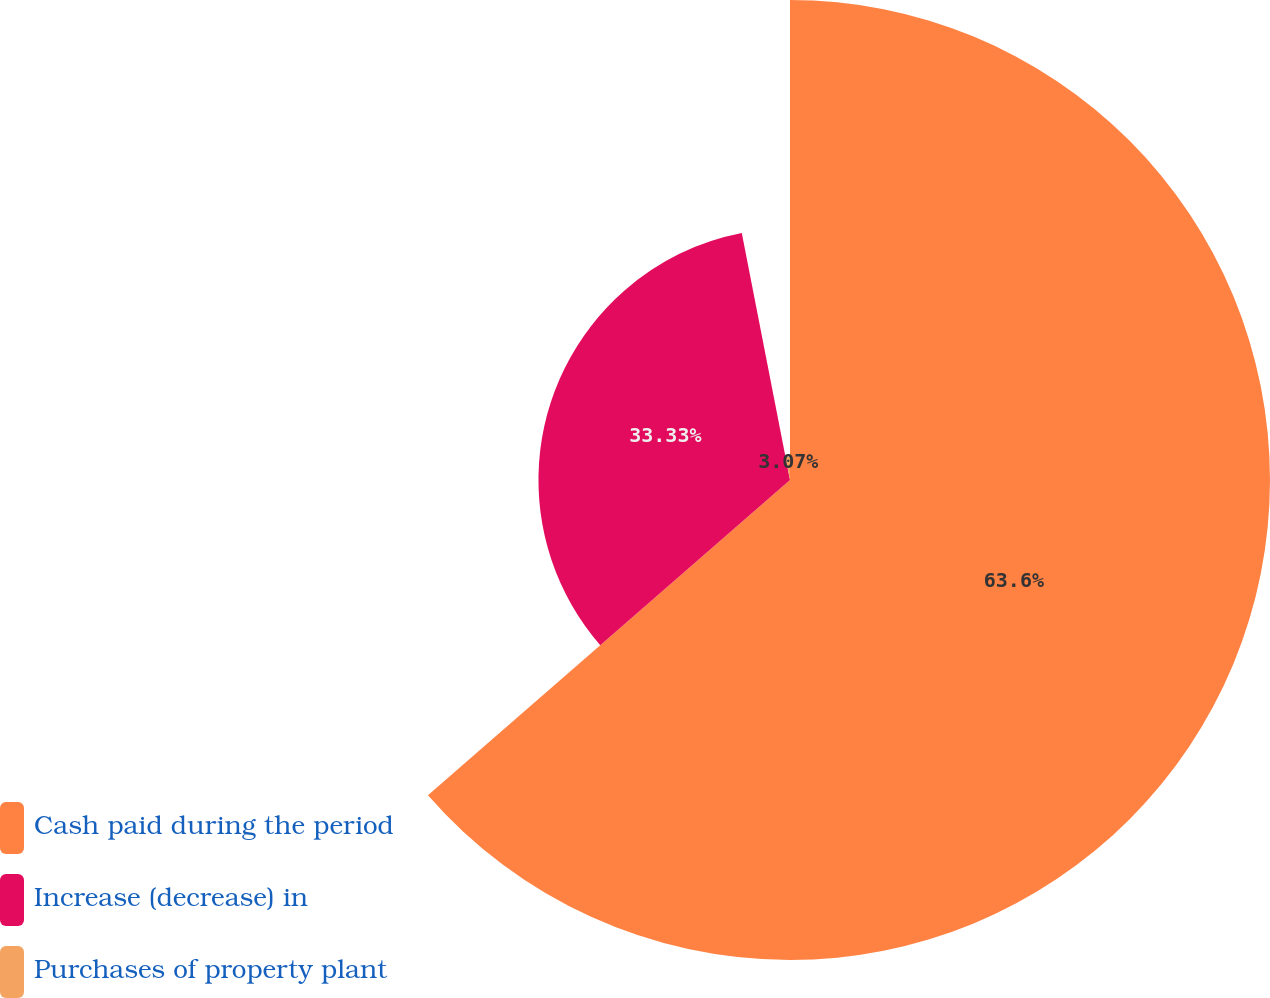Convert chart. <chart><loc_0><loc_0><loc_500><loc_500><pie_chart><fcel>Cash paid during the period<fcel>Increase (decrease) in<fcel>Purchases of property plant<nl><fcel>63.6%<fcel>33.33%<fcel>3.07%<nl></chart> 